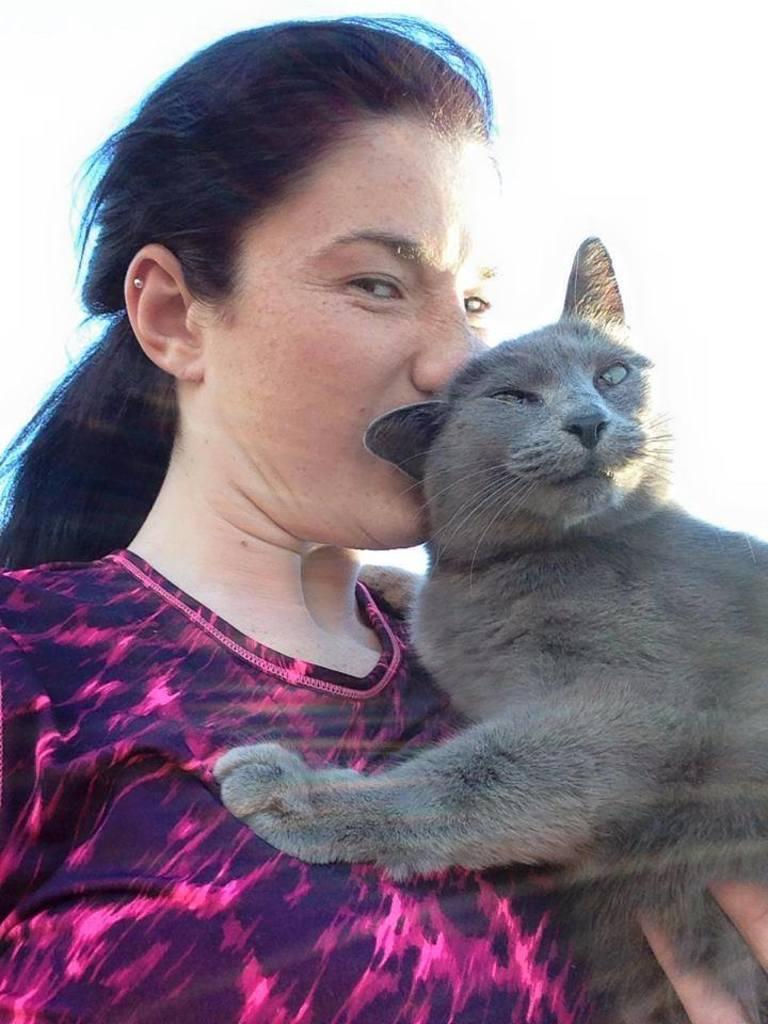Could you give a brief overview of what you see in this image? As we can see in the image there is a woman holding black color cat. 